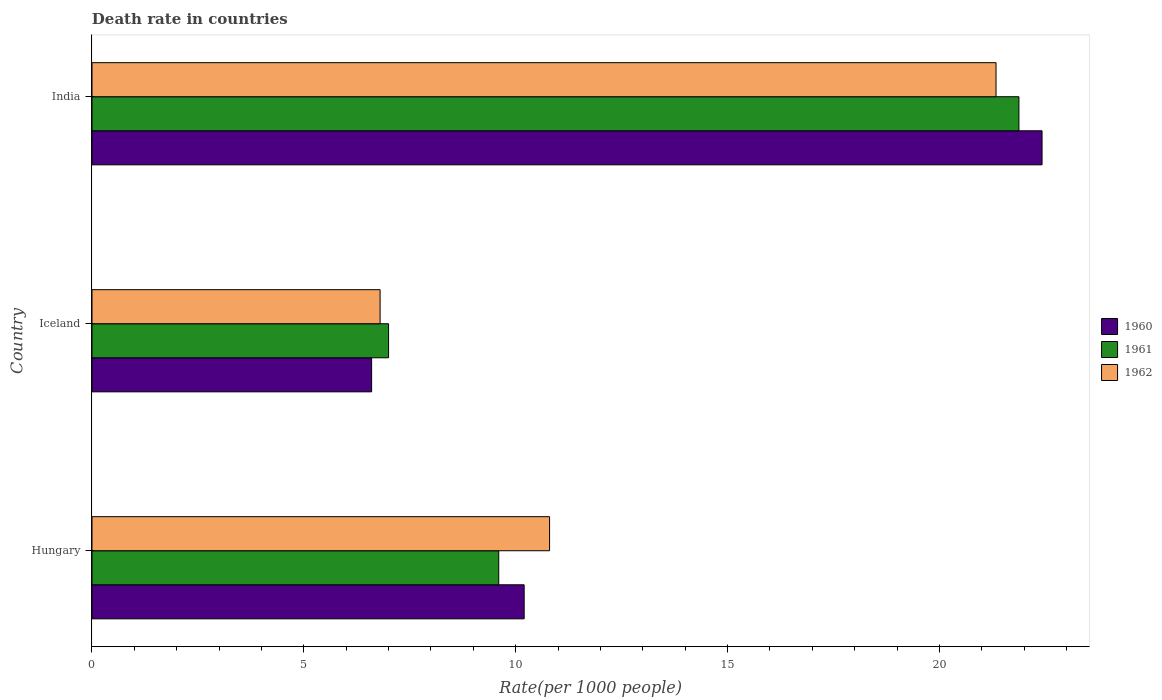How many groups of bars are there?
Your response must be concise. 3. Are the number of bars per tick equal to the number of legend labels?
Your response must be concise. Yes. How many bars are there on the 3rd tick from the top?
Offer a very short reply. 3. How many bars are there on the 3rd tick from the bottom?
Make the answer very short. 3. What is the label of the 1st group of bars from the top?
Keep it short and to the point. India. Across all countries, what is the maximum death rate in 1961?
Make the answer very short. 21.88. Across all countries, what is the minimum death rate in 1960?
Your answer should be compact. 6.6. What is the total death rate in 1962 in the graph?
Make the answer very short. 38.94. What is the difference between the death rate in 1962 in Iceland and that in India?
Give a very brief answer. -14.54. What is the difference between the death rate in 1962 in Iceland and the death rate in 1960 in Hungary?
Offer a terse response. -3.4. What is the average death rate in 1961 per country?
Offer a terse response. 12.83. What is the difference between the death rate in 1962 and death rate in 1960 in Iceland?
Offer a terse response. 0.2. What is the ratio of the death rate in 1961 in Hungary to that in India?
Provide a short and direct response. 0.44. Is the difference between the death rate in 1962 in Hungary and India greater than the difference between the death rate in 1960 in Hungary and India?
Provide a short and direct response. Yes. What is the difference between the highest and the second highest death rate in 1962?
Offer a terse response. 10.54. What is the difference between the highest and the lowest death rate in 1961?
Your answer should be compact. 14.88. In how many countries, is the death rate in 1962 greater than the average death rate in 1962 taken over all countries?
Your answer should be very brief. 1. What does the 2nd bar from the top in Iceland represents?
Offer a very short reply. 1961. Is it the case that in every country, the sum of the death rate in 1960 and death rate in 1961 is greater than the death rate in 1962?
Your answer should be compact. Yes. How many countries are there in the graph?
Your response must be concise. 3. Are the values on the major ticks of X-axis written in scientific E-notation?
Ensure brevity in your answer.  No. Does the graph contain any zero values?
Your response must be concise. No. Does the graph contain grids?
Give a very brief answer. No. How many legend labels are there?
Your answer should be compact. 3. How are the legend labels stacked?
Your response must be concise. Vertical. What is the title of the graph?
Give a very brief answer. Death rate in countries. What is the label or title of the X-axis?
Offer a very short reply. Rate(per 1000 people). What is the Rate(per 1000 people) in 1960 in Hungary?
Ensure brevity in your answer.  10.2. What is the Rate(per 1000 people) in 1962 in Hungary?
Provide a short and direct response. 10.8. What is the Rate(per 1000 people) in 1961 in Iceland?
Make the answer very short. 7. What is the Rate(per 1000 people) of 1960 in India?
Provide a short and direct response. 22.42. What is the Rate(per 1000 people) in 1961 in India?
Offer a terse response. 21.88. What is the Rate(per 1000 people) in 1962 in India?
Ensure brevity in your answer.  21.34. Across all countries, what is the maximum Rate(per 1000 people) in 1960?
Offer a very short reply. 22.42. Across all countries, what is the maximum Rate(per 1000 people) of 1961?
Make the answer very short. 21.88. Across all countries, what is the maximum Rate(per 1000 people) in 1962?
Ensure brevity in your answer.  21.34. Across all countries, what is the minimum Rate(per 1000 people) of 1961?
Your response must be concise. 7. Across all countries, what is the minimum Rate(per 1000 people) of 1962?
Your answer should be very brief. 6.8. What is the total Rate(per 1000 people) in 1960 in the graph?
Ensure brevity in your answer.  39.22. What is the total Rate(per 1000 people) of 1961 in the graph?
Provide a succinct answer. 38.48. What is the total Rate(per 1000 people) in 1962 in the graph?
Provide a short and direct response. 38.94. What is the difference between the Rate(per 1000 people) of 1960 in Hungary and that in India?
Ensure brevity in your answer.  -12.22. What is the difference between the Rate(per 1000 people) of 1961 in Hungary and that in India?
Offer a very short reply. -12.28. What is the difference between the Rate(per 1000 people) in 1962 in Hungary and that in India?
Offer a very short reply. -10.54. What is the difference between the Rate(per 1000 people) of 1960 in Iceland and that in India?
Offer a terse response. -15.82. What is the difference between the Rate(per 1000 people) in 1961 in Iceland and that in India?
Offer a terse response. -14.88. What is the difference between the Rate(per 1000 people) of 1962 in Iceland and that in India?
Your answer should be compact. -14.54. What is the difference between the Rate(per 1000 people) of 1960 in Hungary and the Rate(per 1000 people) of 1961 in Iceland?
Your response must be concise. 3.2. What is the difference between the Rate(per 1000 people) in 1960 in Hungary and the Rate(per 1000 people) in 1962 in Iceland?
Keep it short and to the point. 3.4. What is the difference between the Rate(per 1000 people) of 1960 in Hungary and the Rate(per 1000 people) of 1961 in India?
Keep it short and to the point. -11.68. What is the difference between the Rate(per 1000 people) in 1960 in Hungary and the Rate(per 1000 people) in 1962 in India?
Your answer should be very brief. -11.14. What is the difference between the Rate(per 1000 people) in 1961 in Hungary and the Rate(per 1000 people) in 1962 in India?
Your answer should be compact. -11.74. What is the difference between the Rate(per 1000 people) of 1960 in Iceland and the Rate(per 1000 people) of 1961 in India?
Offer a very short reply. -15.28. What is the difference between the Rate(per 1000 people) of 1960 in Iceland and the Rate(per 1000 people) of 1962 in India?
Your answer should be very brief. -14.74. What is the difference between the Rate(per 1000 people) of 1961 in Iceland and the Rate(per 1000 people) of 1962 in India?
Keep it short and to the point. -14.34. What is the average Rate(per 1000 people) in 1960 per country?
Give a very brief answer. 13.07. What is the average Rate(per 1000 people) of 1961 per country?
Your answer should be compact. 12.83. What is the average Rate(per 1000 people) in 1962 per country?
Keep it short and to the point. 12.98. What is the difference between the Rate(per 1000 people) in 1960 and Rate(per 1000 people) in 1962 in Hungary?
Your response must be concise. -0.6. What is the difference between the Rate(per 1000 people) of 1961 and Rate(per 1000 people) of 1962 in Hungary?
Make the answer very short. -1.2. What is the difference between the Rate(per 1000 people) in 1960 and Rate(per 1000 people) in 1961 in Iceland?
Make the answer very short. -0.4. What is the difference between the Rate(per 1000 people) in 1960 and Rate(per 1000 people) in 1962 in Iceland?
Provide a short and direct response. -0.2. What is the difference between the Rate(per 1000 people) in 1960 and Rate(per 1000 people) in 1961 in India?
Provide a short and direct response. 0.55. What is the difference between the Rate(per 1000 people) of 1960 and Rate(per 1000 people) of 1962 in India?
Offer a very short reply. 1.09. What is the difference between the Rate(per 1000 people) of 1961 and Rate(per 1000 people) of 1962 in India?
Make the answer very short. 0.54. What is the ratio of the Rate(per 1000 people) in 1960 in Hungary to that in Iceland?
Keep it short and to the point. 1.55. What is the ratio of the Rate(per 1000 people) in 1961 in Hungary to that in Iceland?
Make the answer very short. 1.37. What is the ratio of the Rate(per 1000 people) of 1962 in Hungary to that in Iceland?
Your response must be concise. 1.59. What is the ratio of the Rate(per 1000 people) of 1960 in Hungary to that in India?
Provide a succinct answer. 0.45. What is the ratio of the Rate(per 1000 people) in 1961 in Hungary to that in India?
Ensure brevity in your answer.  0.44. What is the ratio of the Rate(per 1000 people) in 1962 in Hungary to that in India?
Your response must be concise. 0.51. What is the ratio of the Rate(per 1000 people) of 1960 in Iceland to that in India?
Offer a very short reply. 0.29. What is the ratio of the Rate(per 1000 people) of 1961 in Iceland to that in India?
Keep it short and to the point. 0.32. What is the ratio of the Rate(per 1000 people) in 1962 in Iceland to that in India?
Offer a terse response. 0.32. What is the difference between the highest and the second highest Rate(per 1000 people) of 1960?
Your answer should be compact. 12.22. What is the difference between the highest and the second highest Rate(per 1000 people) of 1961?
Make the answer very short. 12.28. What is the difference between the highest and the second highest Rate(per 1000 people) of 1962?
Your answer should be very brief. 10.54. What is the difference between the highest and the lowest Rate(per 1000 people) in 1960?
Provide a succinct answer. 15.82. What is the difference between the highest and the lowest Rate(per 1000 people) of 1961?
Offer a terse response. 14.88. What is the difference between the highest and the lowest Rate(per 1000 people) of 1962?
Offer a terse response. 14.54. 